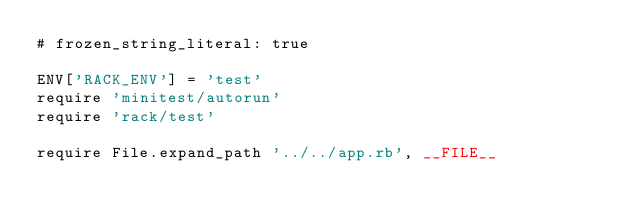Convert code to text. <code><loc_0><loc_0><loc_500><loc_500><_Ruby_># frozen_string_literal: true

ENV['RACK_ENV'] = 'test'
require 'minitest/autorun'
require 'rack/test'

require File.expand_path '../../app.rb', __FILE__
</code> 